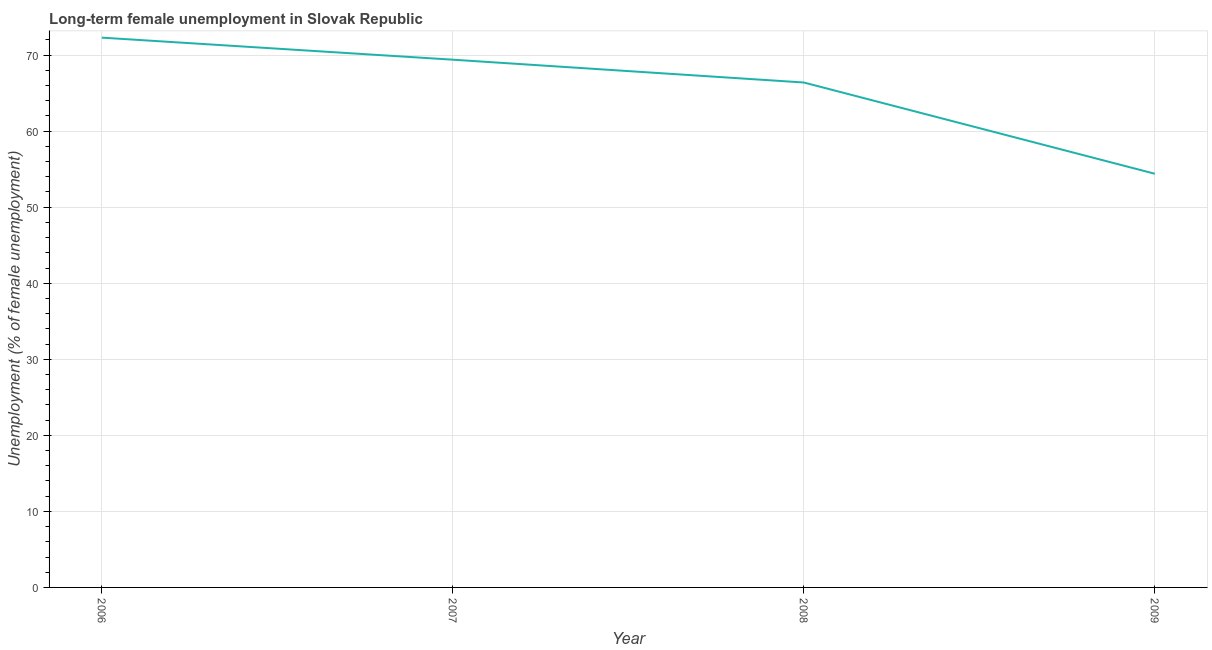What is the long-term female unemployment in 2008?
Your response must be concise. 66.4. Across all years, what is the maximum long-term female unemployment?
Give a very brief answer. 72.3. Across all years, what is the minimum long-term female unemployment?
Provide a succinct answer. 54.4. In which year was the long-term female unemployment minimum?
Your response must be concise. 2009. What is the sum of the long-term female unemployment?
Make the answer very short. 262.5. What is the difference between the long-term female unemployment in 2006 and 2007?
Offer a terse response. 2.9. What is the average long-term female unemployment per year?
Keep it short and to the point. 65.63. What is the median long-term female unemployment?
Provide a short and direct response. 67.9. Do a majority of the years between 2009 and 2006 (inclusive) have long-term female unemployment greater than 62 %?
Give a very brief answer. Yes. What is the ratio of the long-term female unemployment in 2008 to that in 2009?
Give a very brief answer. 1.22. Is the long-term female unemployment in 2007 less than that in 2008?
Your answer should be compact. No. What is the difference between the highest and the second highest long-term female unemployment?
Offer a very short reply. 2.9. What is the difference between the highest and the lowest long-term female unemployment?
Ensure brevity in your answer.  17.9. In how many years, is the long-term female unemployment greater than the average long-term female unemployment taken over all years?
Keep it short and to the point. 3. How many lines are there?
Your answer should be very brief. 1. How many years are there in the graph?
Give a very brief answer. 4. What is the difference between two consecutive major ticks on the Y-axis?
Your answer should be very brief. 10. Are the values on the major ticks of Y-axis written in scientific E-notation?
Your answer should be very brief. No. What is the title of the graph?
Your answer should be compact. Long-term female unemployment in Slovak Republic. What is the label or title of the Y-axis?
Your answer should be very brief. Unemployment (% of female unemployment). What is the Unemployment (% of female unemployment) in 2006?
Your answer should be very brief. 72.3. What is the Unemployment (% of female unemployment) of 2007?
Your response must be concise. 69.4. What is the Unemployment (% of female unemployment) of 2008?
Give a very brief answer. 66.4. What is the Unemployment (% of female unemployment) of 2009?
Ensure brevity in your answer.  54.4. What is the difference between the Unemployment (% of female unemployment) in 2006 and 2008?
Your response must be concise. 5.9. What is the difference between the Unemployment (% of female unemployment) in 2006 and 2009?
Keep it short and to the point. 17.9. What is the ratio of the Unemployment (% of female unemployment) in 2006 to that in 2007?
Keep it short and to the point. 1.04. What is the ratio of the Unemployment (% of female unemployment) in 2006 to that in 2008?
Offer a terse response. 1.09. What is the ratio of the Unemployment (% of female unemployment) in 2006 to that in 2009?
Keep it short and to the point. 1.33. What is the ratio of the Unemployment (% of female unemployment) in 2007 to that in 2008?
Provide a succinct answer. 1.04. What is the ratio of the Unemployment (% of female unemployment) in 2007 to that in 2009?
Provide a succinct answer. 1.28. What is the ratio of the Unemployment (% of female unemployment) in 2008 to that in 2009?
Keep it short and to the point. 1.22. 